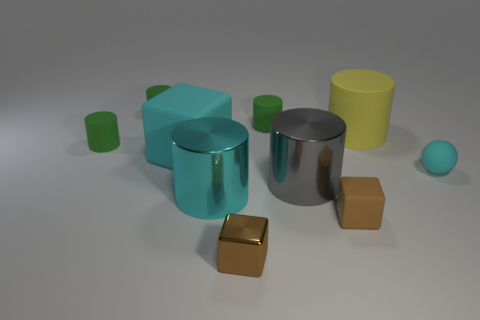Subtract all green cubes. How many green cylinders are left? 3 Subtract all big rubber cylinders. How many cylinders are left? 5 Subtract all cyan cylinders. How many cylinders are left? 5 Subtract all purple cylinders. Subtract all green blocks. How many cylinders are left? 6 Subtract all cylinders. How many objects are left? 4 Add 4 large purple rubber things. How many large purple rubber things exist? 4 Subtract 1 cyan balls. How many objects are left? 9 Subtract all tiny blue objects. Subtract all small rubber objects. How many objects are left? 5 Add 2 tiny spheres. How many tiny spheres are left? 3 